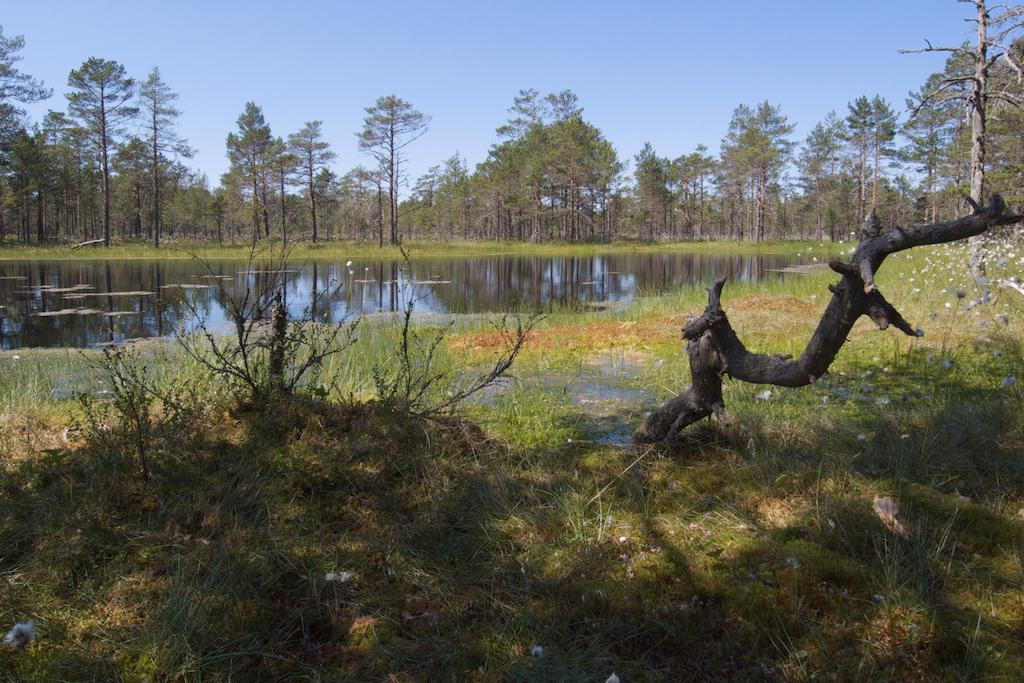What type of vegetation can be seen in the image? There is grass in the image. What other natural elements are present in the image? There are trees and water visible in the image. What can be seen in the background of the image? The sky is visible in the background of the image. How many yams are being harvested in the image? There are no yams present in the image; it features grass, trees, water, and the sky. Are there any clams visible in the water in the image? There are no clams visible in the water in the image; it only shows the water's surface. 